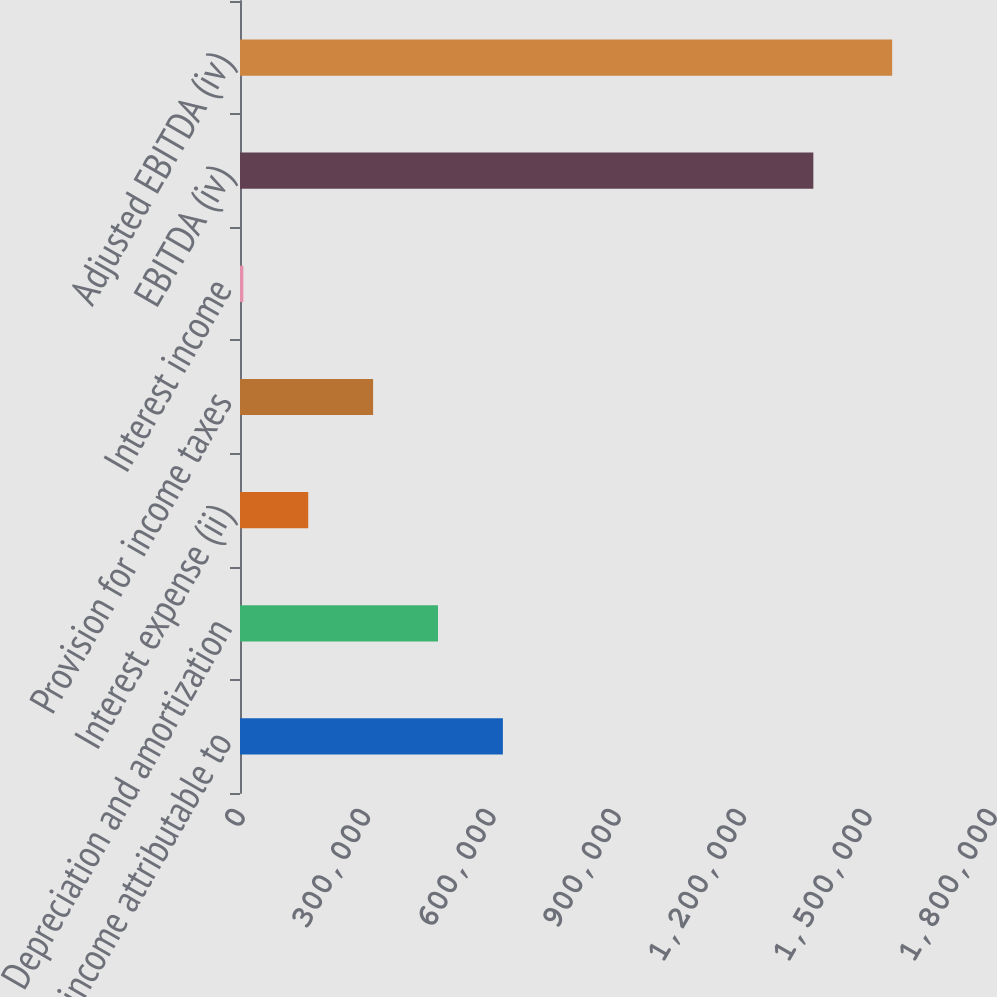Convert chart. <chart><loc_0><loc_0><loc_500><loc_500><bar_chart><fcel>Net income attributable to<fcel>Depreciation and amortization<fcel>Interest expense (ii)<fcel>Provision for income taxes<fcel>Interest income<fcel>EBITDA (iv)<fcel>Adjusted EBITDA (iv)<nl><fcel>629232<fcel>473937<fcel>163346<fcel>318641<fcel>8051<fcel>1.37236e+06<fcel>1.561e+06<nl></chart> 